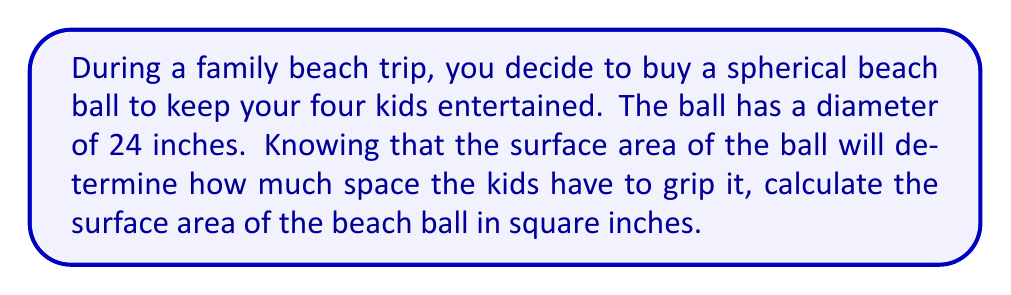Could you help me with this problem? To solve this problem, we'll follow these steps:

1. Recall the formula for the surface area of a sphere:
   $$A = 4\pi r^2$$
   where $A$ is the surface area and $r$ is the radius of the sphere.

2. We're given the diameter of the beach ball, which is 24 inches. The radius is half of the diameter:
   $$r = \frac{24}{2} = 12\text{ inches}$$

3. Now, let's substitute this value into our formula:
   $$A = 4\pi (12)^2$$

4. Simplify the expression inside the parentheses:
   $$A = 4\pi (144)$$

5. Multiply:
   $$A = 576\pi$$

6. To get a decimal approximation, we can use $\pi \approx 3.14159$:
   $$A \approx 576 \times 3.14159 \approx 1809.56\text{ square inches}$$

Therefore, the surface area of the beach ball is approximately 1809.56 square inches.
Answer: $576\pi$ or approximately 1809.56 square inches 